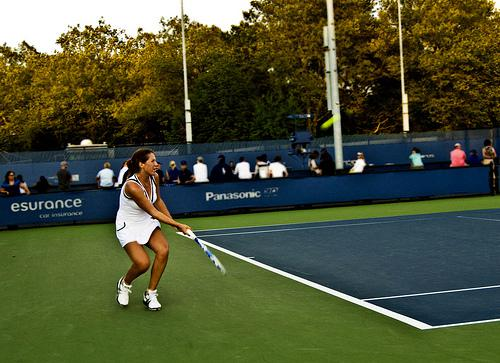Question: what is the woman doing?
Choices:
A. Sleeping.
B. Playing tennis.
C. Eating.
D. Swimming.
Answer with the letter. Answer: B Question: what color is the racket?
Choices:
A. White.
B. It is blue and white.
C. Black.
D. Red.
Answer with the letter. Answer: B Question: why is this woman in motion?
Choices:
A. She is running.
B. She is shooting a bow.
C. To hit the ball.
D. She is catching a frisbee.
Answer with the letter. Answer: C Question: who is the picture focused on?
Choices:
A. Boy.
B. Man.
C. The woman playing.
D. Teacher.
Answer with the letter. Answer: C Question: when was this photo taken?
Choices:
A. During a game of tennis.
B. While eating breakfast.
C. During a fireworks show.
D. During a fishing trip.
Answer with the letter. Answer: A Question: when was the picture taken?
Choices:
A. Nighttime.
B. In the daylight.
C. Sunrise.
D. Sunset.
Answer with the letter. Answer: B Question: who took the picture?
Choices:
A. A photographer.
B. A child.
C. An actress.
D. A writer.
Answer with the letter. Answer: A Question: where was picture taken?
Choices:
A. In a bathroom.
B. In a field.
C. On tennis court.
D. On a beach.
Answer with the letter. Answer: C Question: where was this photo taken?
Choices:
A. Church.
B. School.
C. On a tennis court.
D. Kitchen.
Answer with the letter. Answer: C Question: how many people is the focus of this photo?
Choices:
A. Just one.
B. 2.
C. 3.
D. 4.
Answer with the letter. Answer: A Question: what color is trimmed around blue?
Choices:
A. White.
B. Black.
C. Red.
D. Brown.
Answer with the letter. Answer: A 